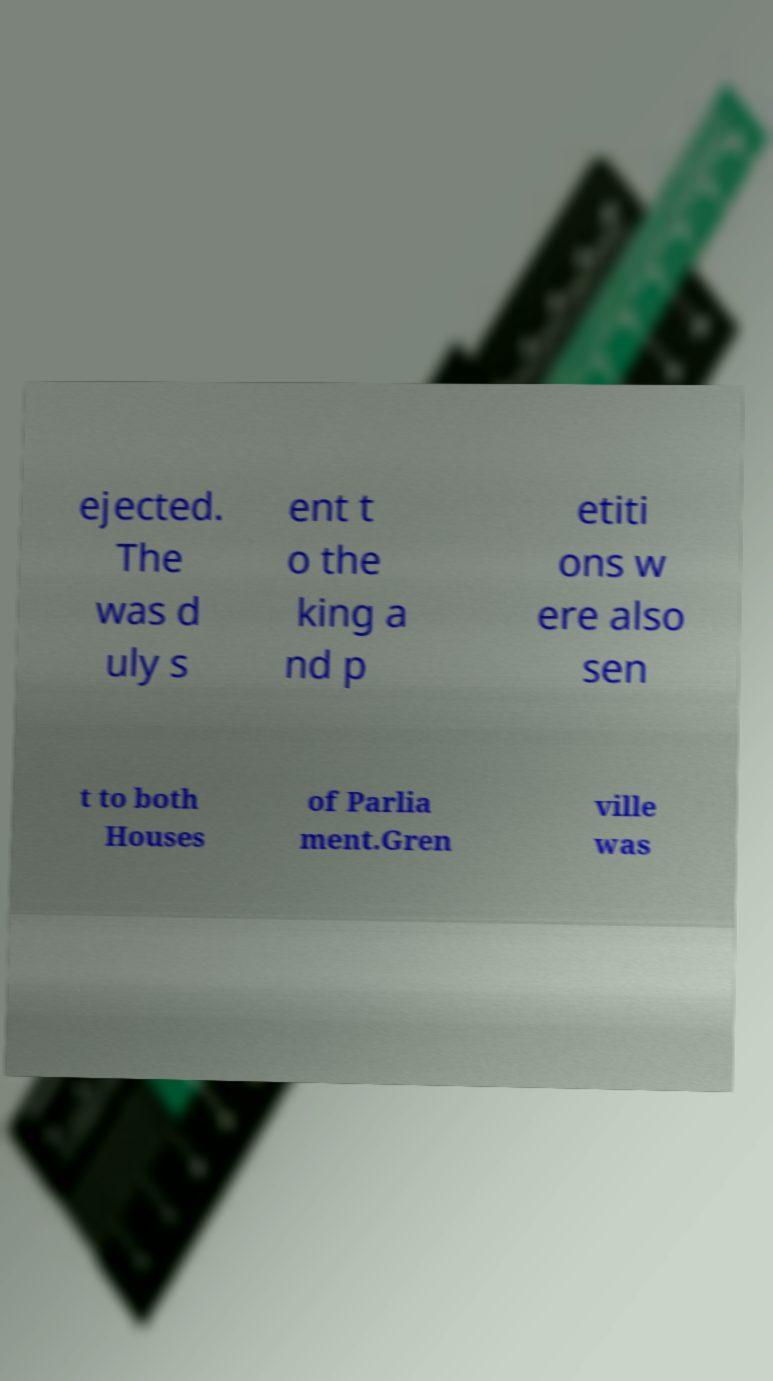Could you extract and type out the text from this image? ejected. The was d uly s ent t o the king a nd p etiti ons w ere also sen t to both Houses of Parlia ment.Gren ville was 